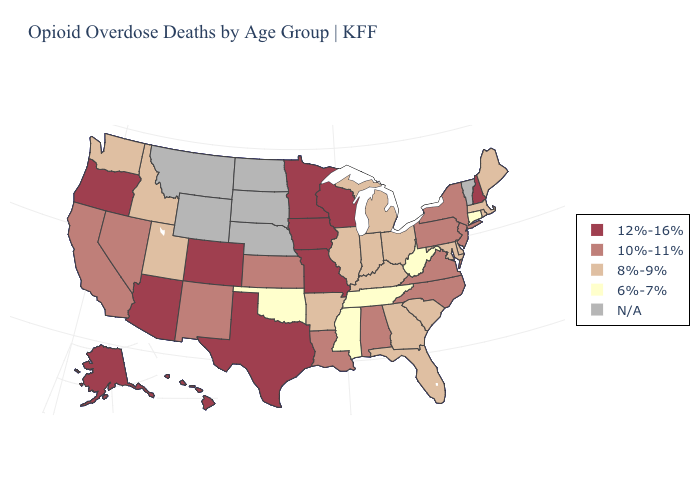What is the value of Wisconsin?
Short answer required. 12%-16%. Which states have the highest value in the USA?
Concise answer only. Alaska, Arizona, Colorado, Hawaii, Iowa, Minnesota, Missouri, New Hampshire, Oregon, Texas, Wisconsin. Among the states that border Georgia , does South Carolina have the lowest value?
Short answer required. No. What is the lowest value in states that border Iowa?
Write a very short answer. 8%-9%. What is the value of New Mexico?
Be succinct. 10%-11%. Which states have the highest value in the USA?
Quick response, please. Alaska, Arizona, Colorado, Hawaii, Iowa, Minnesota, Missouri, New Hampshire, Oregon, Texas, Wisconsin. What is the lowest value in the USA?
Keep it brief. 6%-7%. Among the states that border West Virginia , which have the lowest value?
Quick response, please. Kentucky, Maryland, Ohio. What is the value of Louisiana?
Quick response, please. 10%-11%. Name the states that have a value in the range 10%-11%?
Short answer required. Alabama, California, Kansas, Louisiana, Nevada, New Jersey, New Mexico, New York, North Carolina, Pennsylvania, Virginia. Does Georgia have the highest value in the USA?
Short answer required. No. Name the states that have a value in the range 8%-9%?
Keep it brief. Arkansas, Delaware, Florida, Georgia, Idaho, Illinois, Indiana, Kentucky, Maine, Maryland, Massachusetts, Michigan, Ohio, Rhode Island, South Carolina, Utah, Washington. What is the value of Georgia?
Quick response, please. 8%-9%. Name the states that have a value in the range N/A?
Be succinct. Montana, Nebraska, North Dakota, South Dakota, Vermont, Wyoming. 